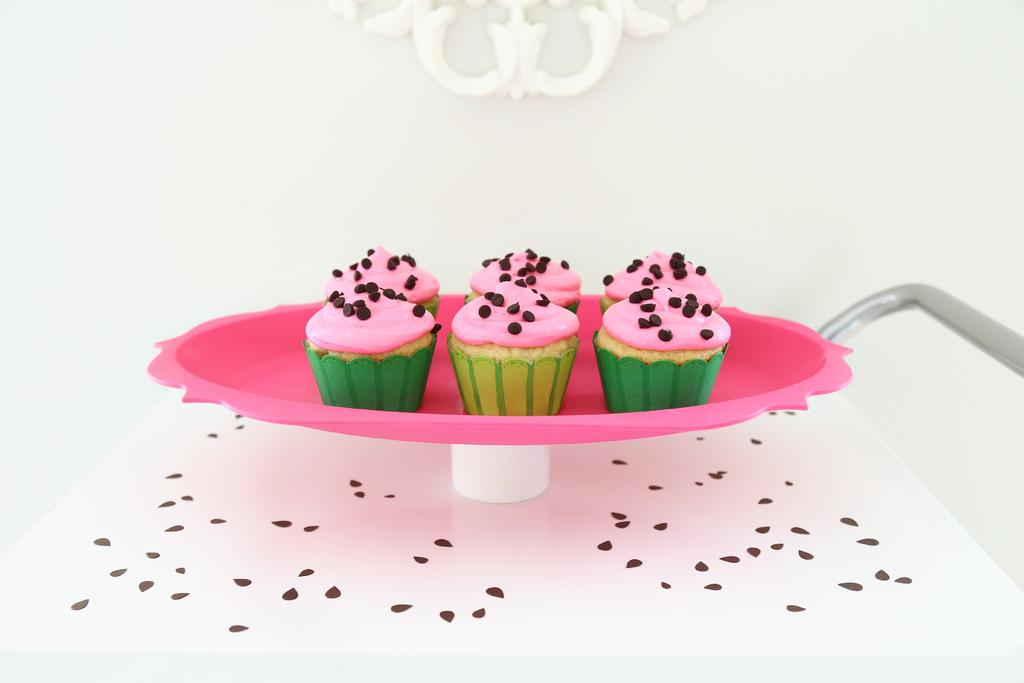What is on the tray that is visible in the image? There is a tray with cupcakes in the image. Where is the tray located in the image? The tray is placed on a platform. What can be seen in the background of the image? There is a wall in the background of the image. What type of print can be seen on the wall in the image? There is no print visible on the wall in the image; only a plain wall is present. 